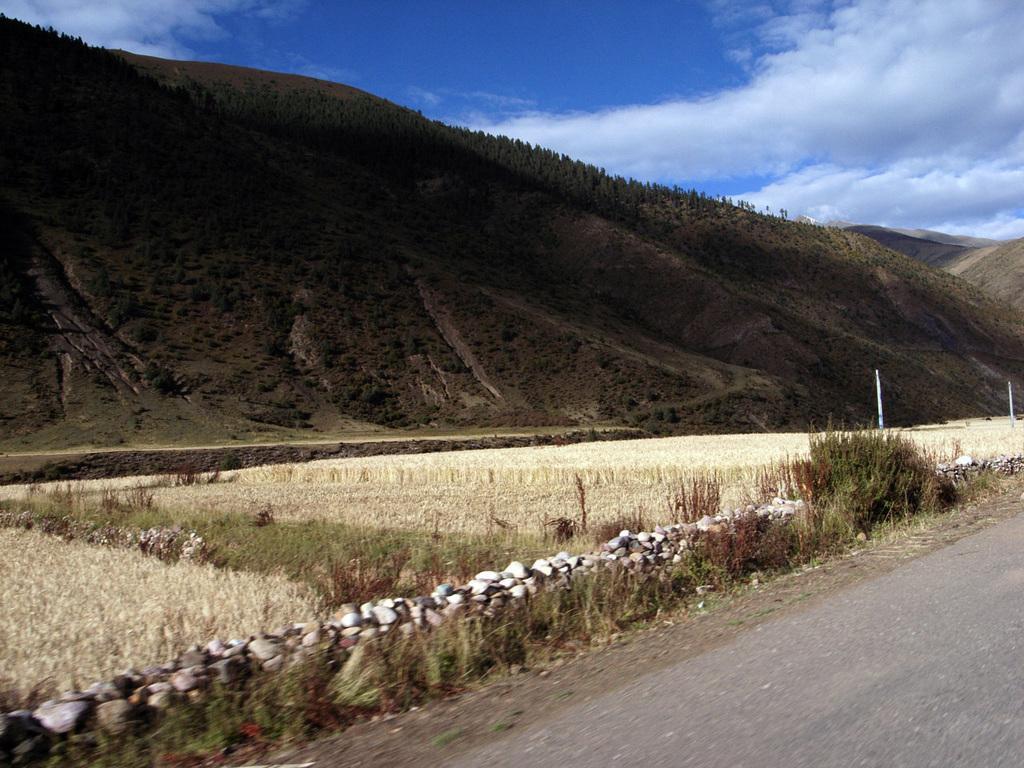Could you give a brief overview of what you see in this image? In this image there is a road, beside that there is a grass and also mountains filled with trees. Also there are clouds in the sky. 